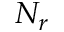<formula> <loc_0><loc_0><loc_500><loc_500>N _ { r }</formula> 